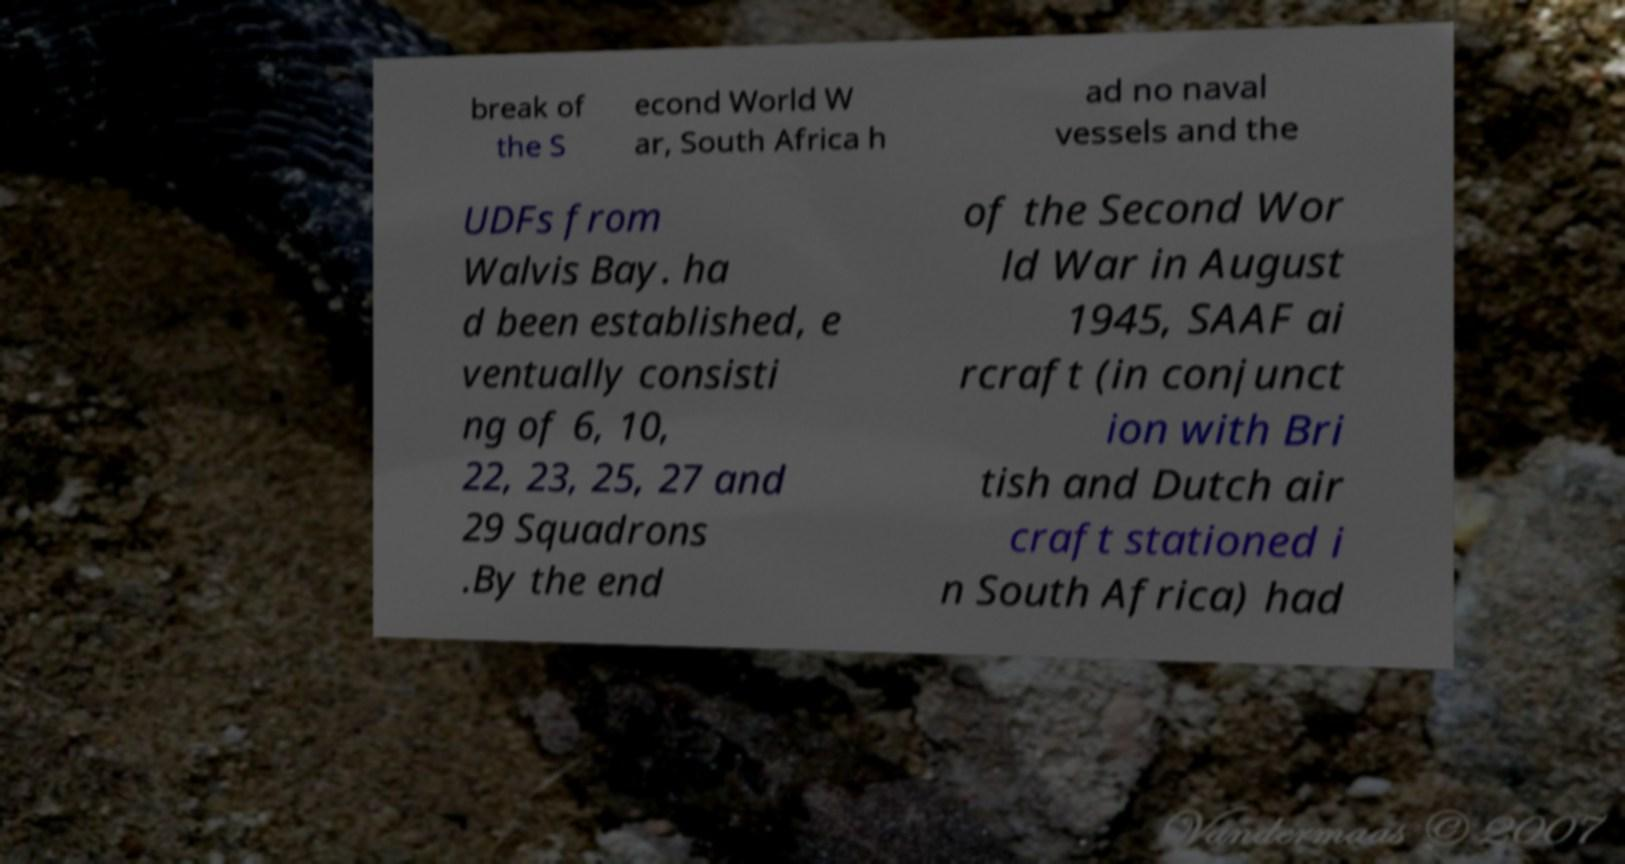Could you assist in decoding the text presented in this image and type it out clearly? break of the S econd World W ar, South Africa h ad no naval vessels and the UDFs from Walvis Bay. ha d been established, e ventually consisti ng of 6, 10, 22, 23, 25, 27 and 29 Squadrons .By the end of the Second Wor ld War in August 1945, SAAF ai rcraft (in conjunct ion with Bri tish and Dutch air craft stationed i n South Africa) had 